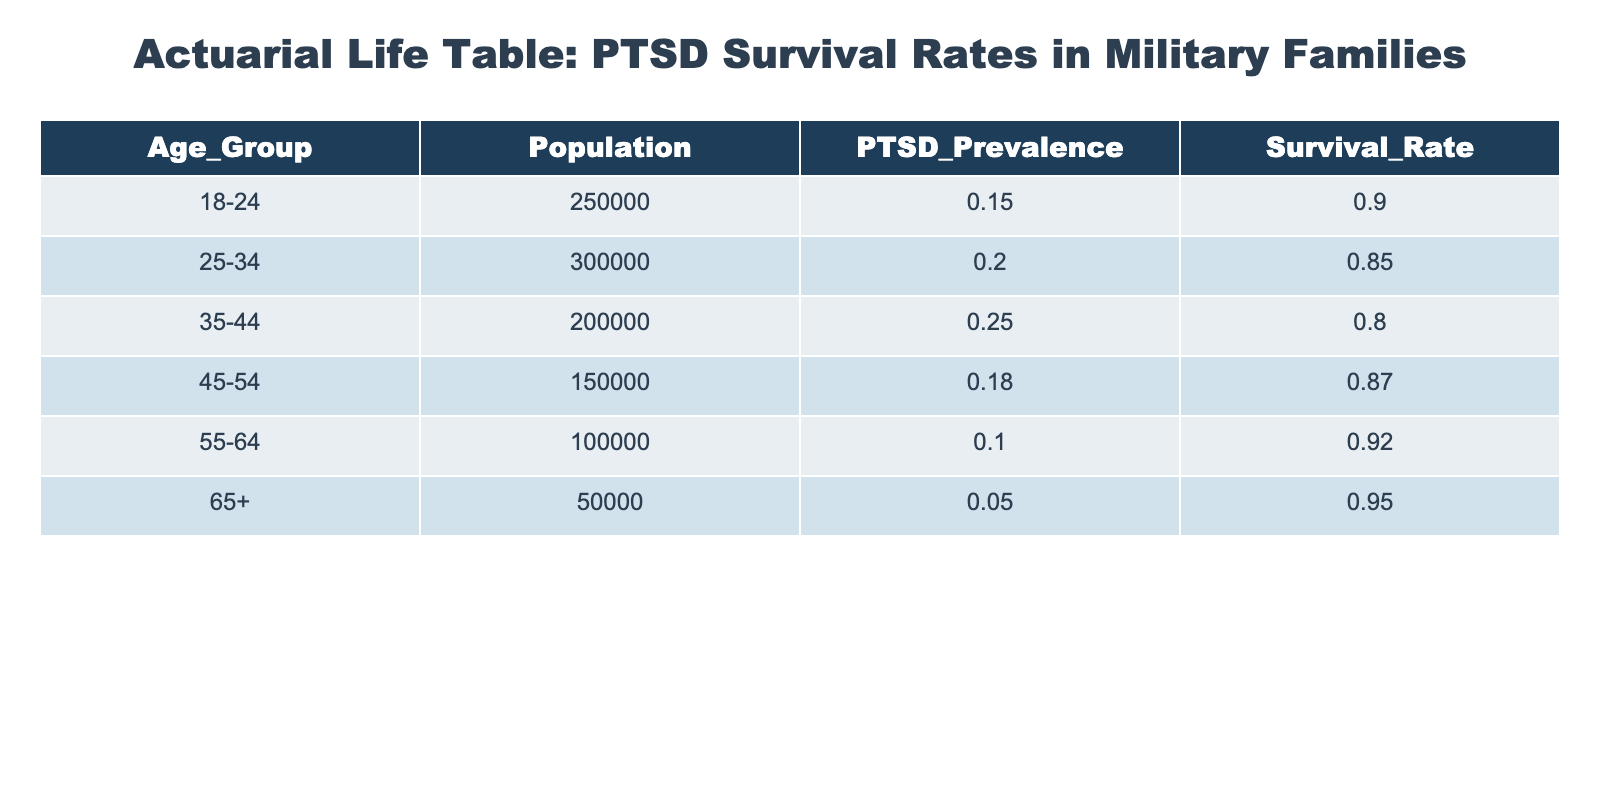What is the survival rate for the 25-34 age group? Referring directly to the table, we can see that the survival rate for the 25-34 age group is listed as 0.85.
Answer: 0.85 Which age group has the highest prevalence of PTSD? By examining the PTSD prevalence column, the highest value is 0.25, which corresponds to the 35-44 age group.
Answer: 35-44 What is the total population of all age groups combined? To find the total population, we add the populations of all age groups: 250000 + 300000 + 200000 + 150000 + 100000 + 50000 = 1050000.
Answer: 1050000 Is it true that the survival rate is highest for the 55-64 age group? Checking the survival rates in the table, the rate for the 55-64 group is 0.92, while for other groups (such as 65+ at 0.95), it is not the highest. Therefore, the statement is false.
Answer: No What is the average survival rate across all age groups? To find the average, we sum the survival rates: 0.90 + 0.85 + 0.80 + 0.87 + 0.92 + 0.95 = 5.29. Then, we divide by the number of age groups (which is 6): 5.29 / 6 = 0.8817, approximately 0.88.
Answer: 0.88 Which age group has the lowest PTSD prevalence? By scanning the PTSD prevalence column, the lowest value is 0.05, which is for the 65+ age group.
Answer: 65+ If the 35-44 age group had a 10% increase in survival rate, what would their new rate be? Starting with the current survival rate of 0.80 for the 35-44 age group, a 10% increase means we add 0.10 * 0.80 = 0.08 to the current rate. So, 0.80 + 0.08 = 0.88.
Answer: 0.88 What is the sum of the populations of the 18-24 and 45-54 age groups? The population for the 18-24 group is 250000, and for the 45-54 group, it is 150000. Adding these together gives us 250000 + 150000 = 400000.
Answer: 400000 